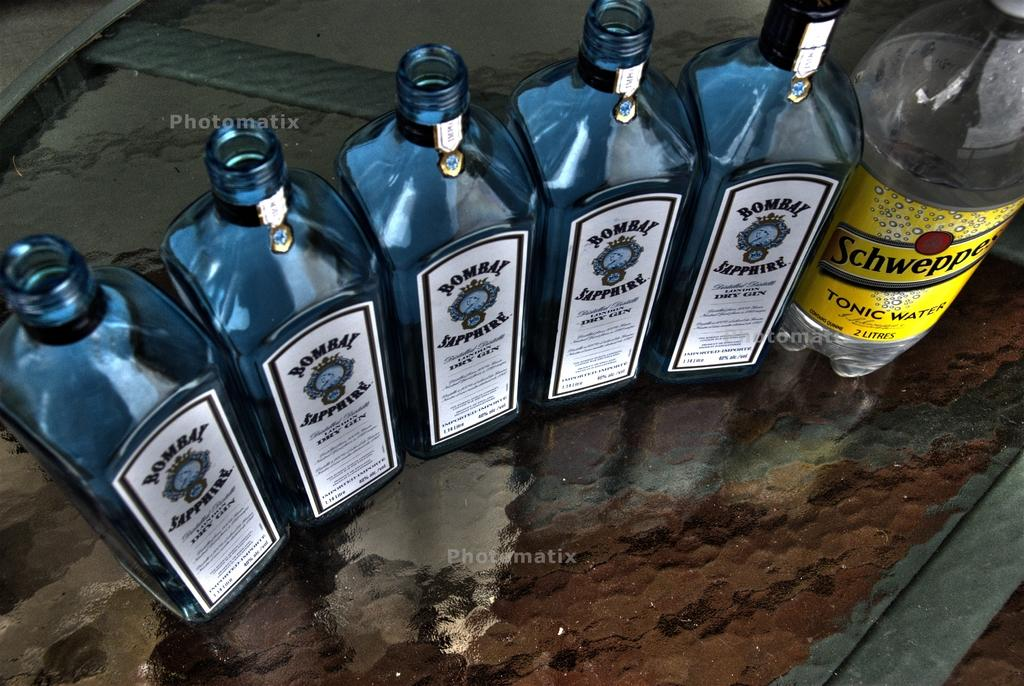<image>
Summarize the visual content of the image. A bottle of Schweepes Tonic water is next to five bottle of Bombay Sapphire. 